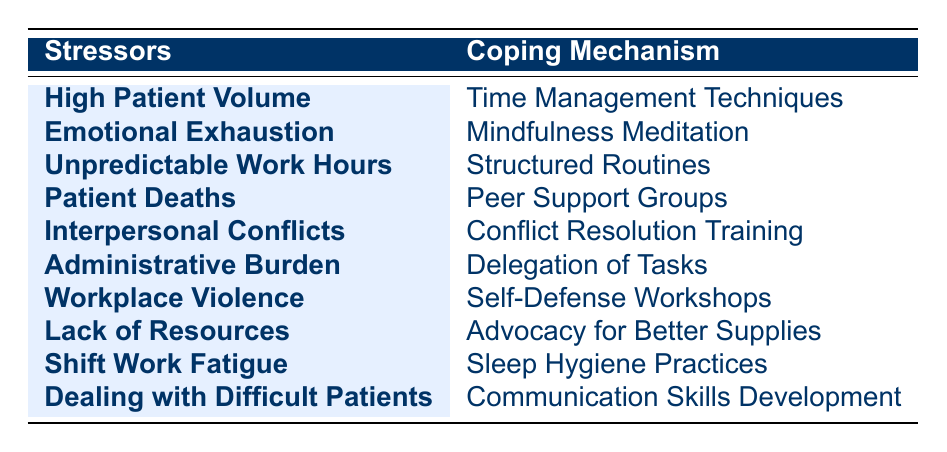What coping mechanism is associated with emotional exhaustion? The table shows that emotional exhaustion is paired with mindfulness meditation as its coping mechanism. This can be directly retrieved from the corresponding row in the table.
Answer: Mindfulness meditation Is peer support groups used for dealing with shift work fatigue? The table indicates that peer support groups are associated with patient deaths, while shift work fatigue is linked to sleep hygiene practices, meaning peer support groups are not used for shift work fatigue.
Answer: No Which coping mechanism is linked to workplace violence? According to the table, workplace violence is associated with self-defense workshops, which can be directly found in the relevant row.
Answer: Self-defense workshops How many stressors have structured routines as their coping mechanism? The table lists structured routines only associated with unpredictable work hours. Thus, there is only one stressor connected to this coping mechanism.
Answer: 1 Which stressor is associated with the delegation of tasks as a coping mechanism? From the table, we can identify that the administrative burden is paired with the delegation of tasks, allowing us to directly reference the corresponding entry.
Answer: Administrative burden Are communication skills development used to address emotional exhaustion? By examining the table, communication skills development is related to dealing with difficult patients, while emotional exhaustion is dealt with using mindfulness meditation, thus clarifying that they are not connected.
Answer: No What is the total number of unique stressors listed in the table? The table lists ten different stressors, and by counting the unique entries under the 'Stressors' column, we confirm that the total is indeed ten.
Answer: 10 Identify the coping mechanism associated with high patient volume. The table clearly states that time management techniques are linked with high patient volume as its coping mechanism, and this can be easily found in the relevant row.
Answer: Time management techniques Are there more coping mechanisms for emotional exhaustion than for interpersonal conflicts? The table shows that emotional exhaustion has one coping mechanism (mindfulness meditation), while interpersonal conflicts also have one (conflict resolution training). Since both have the same count, the answer is no.
Answer: No What coping mechanism do nurses use when they face lack of resources? The table states that advocates for better supplies is the coping mechanism associated with lack of resources, which can be directly seen when reviewing the relevant row.
Answer: Advocacy for better supplies 